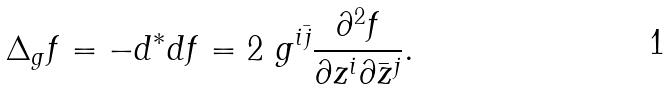Convert formula to latex. <formula><loc_0><loc_0><loc_500><loc_500>\Delta _ { g } f = - d ^ { * } d f = 2 \ g ^ { i \bar { j } } \frac { \partial ^ { 2 } f } { \partial z ^ { i } \partial \bar { z } ^ { j } } .</formula> 